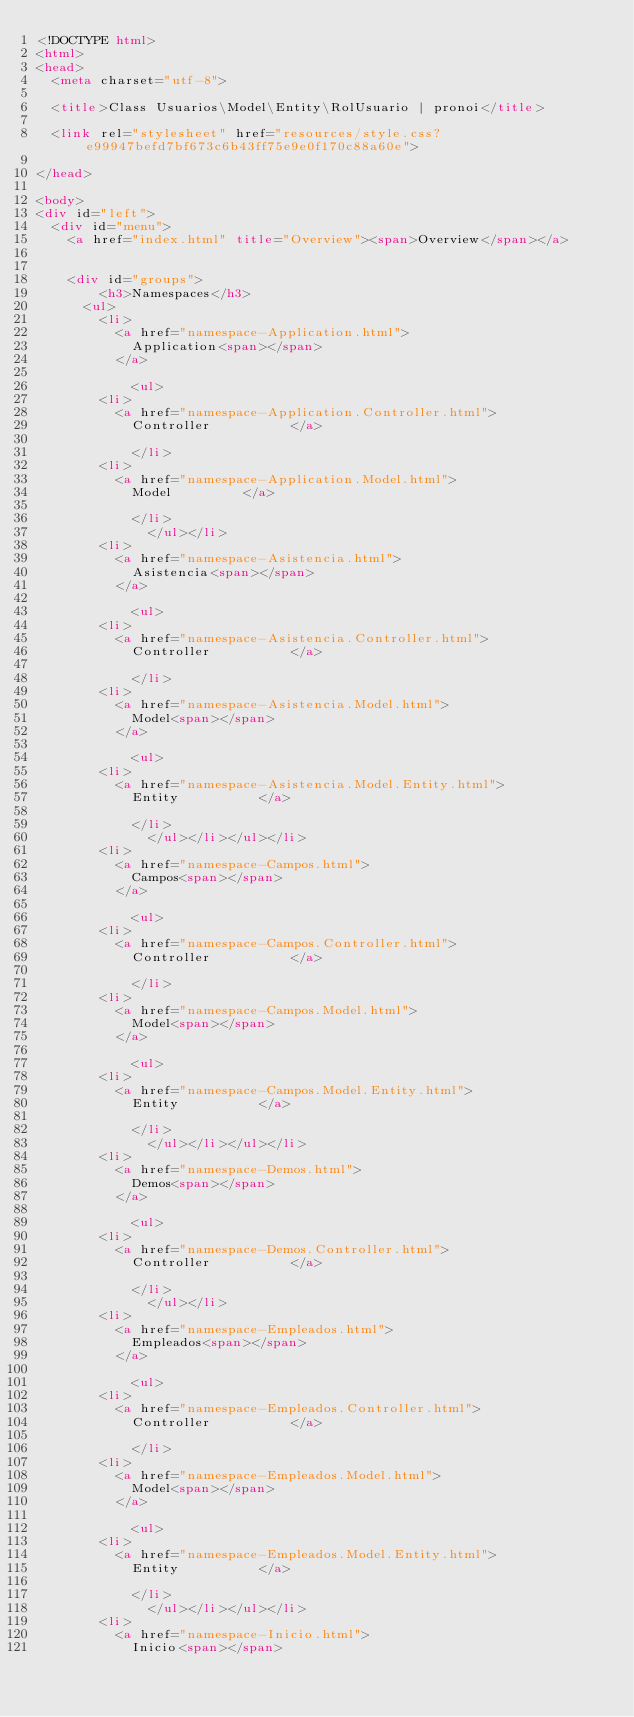Convert code to text. <code><loc_0><loc_0><loc_500><loc_500><_HTML_><!DOCTYPE html>
<html>
<head>
	<meta charset="utf-8">

	<title>Class Usuarios\Model\Entity\RolUsuario | pronoi</title>

	<link rel="stylesheet" href="resources/style.css?e99947befd7bf673c6b43ff75e9e0f170c88a60e">

</head>

<body>
<div id="left">
	<div id="menu">
		<a href="index.html" title="Overview"><span>Overview</span></a>


		<div id="groups">
				<h3>Namespaces</h3>
			<ul>
				<li>
					<a href="namespace-Application.html">
						Application<span></span>
					</a>

						<ul>
				<li>
					<a href="namespace-Application.Controller.html">
						Controller					</a>

						</li>
				<li>
					<a href="namespace-Application.Model.html">
						Model					</a>

						</li>
							</ul></li>
				<li>
					<a href="namespace-Asistencia.html">
						Asistencia<span></span>
					</a>

						<ul>
				<li>
					<a href="namespace-Asistencia.Controller.html">
						Controller					</a>

						</li>
				<li>
					<a href="namespace-Asistencia.Model.html">
						Model<span></span>
					</a>

						<ul>
				<li>
					<a href="namespace-Asistencia.Model.Entity.html">
						Entity					</a>

						</li>
							</ul></li></ul></li>
				<li>
					<a href="namespace-Campos.html">
						Campos<span></span>
					</a>

						<ul>
				<li>
					<a href="namespace-Campos.Controller.html">
						Controller					</a>

						</li>
				<li>
					<a href="namespace-Campos.Model.html">
						Model<span></span>
					</a>

						<ul>
				<li>
					<a href="namespace-Campos.Model.Entity.html">
						Entity					</a>

						</li>
							</ul></li></ul></li>
				<li>
					<a href="namespace-Demos.html">
						Demos<span></span>
					</a>

						<ul>
				<li>
					<a href="namespace-Demos.Controller.html">
						Controller					</a>

						</li>
							</ul></li>
				<li>
					<a href="namespace-Empleados.html">
						Empleados<span></span>
					</a>

						<ul>
				<li>
					<a href="namespace-Empleados.Controller.html">
						Controller					</a>

						</li>
				<li>
					<a href="namespace-Empleados.Model.html">
						Model<span></span>
					</a>

						<ul>
				<li>
					<a href="namespace-Empleados.Model.Entity.html">
						Entity					</a>

						</li>
							</ul></li></ul></li>
				<li>
					<a href="namespace-Inicio.html">
						Inicio<span></span></code> 